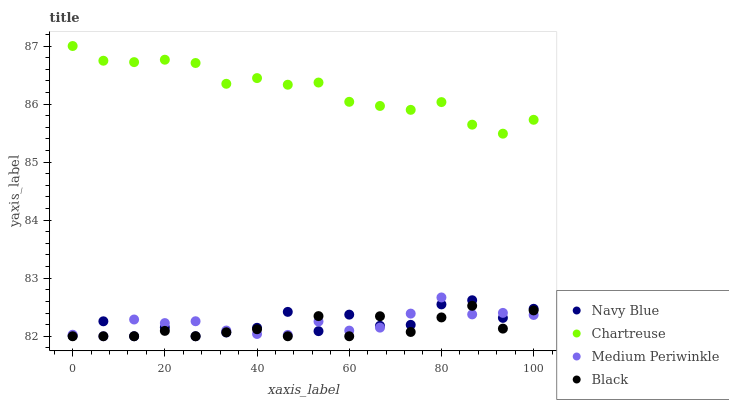Does Black have the minimum area under the curve?
Answer yes or no. Yes. Does Chartreuse have the maximum area under the curve?
Answer yes or no. Yes. Does Medium Periwinkle have the minimum area under the curve?
Answer yes or no. No. Does Medium Periwinkle have the maximum area under the curve?
Answer yes or no. No. Is Medium Periwinkle the smoothest?
Answer yes or no. Yes. Is Navy Blue the roughest?
Answer yes or no. Yes. Is Chartreuse the smoothest?
Answer yes or no. No. Is Chartreuse the roughest?
Answer yes or no. No. Does Navy Blue have the lowest value?
Answer yes or no. Yes. Does Chartreuse have the lowest value?
Answer yes or no. No. Does Chartreuse have the highest value?
Answer yes or no. Yes. Does Medium Periwinkle have the highest value?
Answer yes or no. No. Is Black less than Chartreuse?
Answer yes or no. Yes. Is Chartreuse greater than Black?
Answer yes or no. Yes. Does Black intersect Navy Blue?
Answer yes or no. Yes. Is Black less than Navy Blue?
Answer yes or no. No. Is Black greater than Navy Blue?
Answer yes or no. No. Does Black intersect Chartreuse?
Answer yes or no. No. 